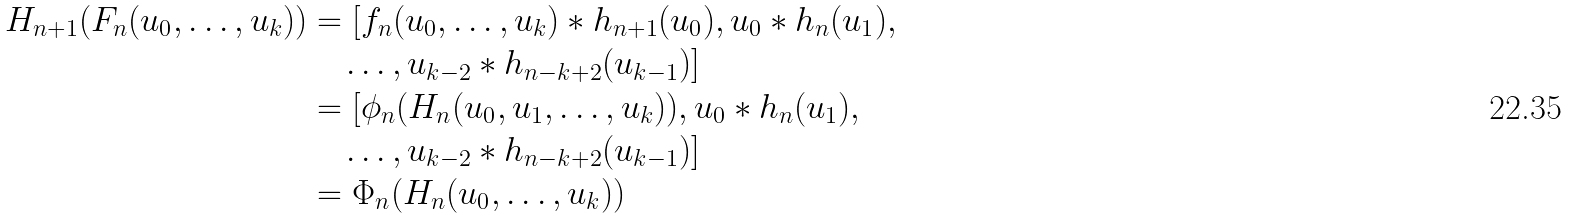<formula> <loc_0><loc_0><loc_500><loc_500>H _ { n + 1 } ( F _ { n } ( u _ { 0 } , \dots , u _ { k } ) ) & = [ f _ { n } ( u _ { 0 } , \dots , u _ { k } ) \ast h _ { n + 1 } ( u _ { 0 } ) , u _ { 0 } \ast h _ { n } ( u _ { 1 } ) , \\ & \quad \dots , u _ { k - 2 } \ast h _ { n - k + 2 } ( u _ { k - 1 } ) ] \\ & = [ \phi _ { n } ( H _ { n } ( u _ { 0 } , u _ { 1 } , \dots , u _ { k } ) ) , u _ { 0 } \ast h _ { n } ( u _ { 1 } ) , \\ & \quad \dots , u _ { k - 2 } \ast h _ { n - k + 2 } ( u _ { k - 1 } ) ] \\ & = \Phi _ { n } ( H _ { n } ( u _ { 0 } , \dots , u _ { k } ) )</formula> 